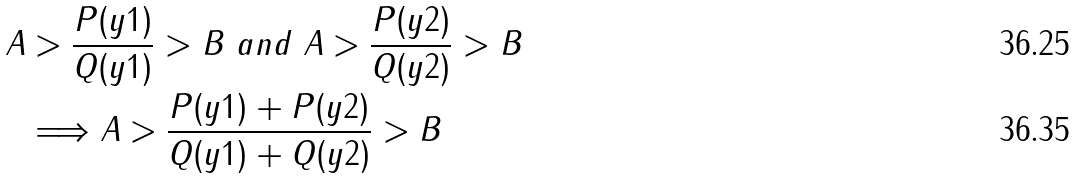<formula> <loc_0><loc_0><loc_500><loc_500>A & > \frac { P ( y 1 ) } { Q ( y 1 ) } > B \text { } a n d \text { } A > \frac { P ( y 2 ) } { Q ( y 2 ) } > B \\ & \Longrightarrow A > \frac { P ( y 1 ) + P ( y 2 ) } { Q ( y 1 ) + Q ( y 2 ) } > B</formula> 